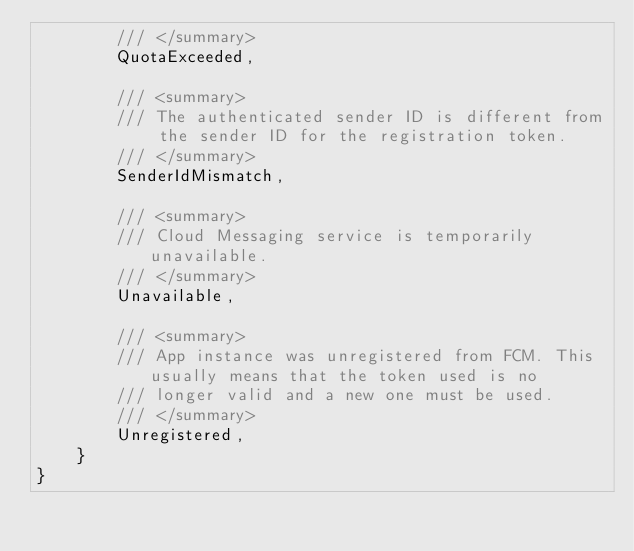Convert code to text. <code><loc_0><loc_0><loc_500><loc_500><_C#_>        /// </summary>
        QuotaExceeded,

        /// <summary>
        /// The authenticated sender ID is different from the sender ID for the registration token.
        /// </summary>
        SenderIdMismatch,

        /// <summary>
        /// Cloud Messaging service is temporarily unavailable.
        /// </summary>
        Unavailable,

        /// <summary>
        /// App instance was unregistered from FCM. This usually means that the token used is no
        /// longer valid and a new one must be used.
        /// </summary>
        Unregistered,
    }
}
</code> 